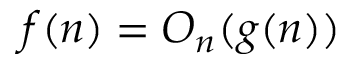<formula> <loc_0><loc_0><loc_500><loc_500>f ( n ) = O _ { n } ( g ( n ) )</formula> 